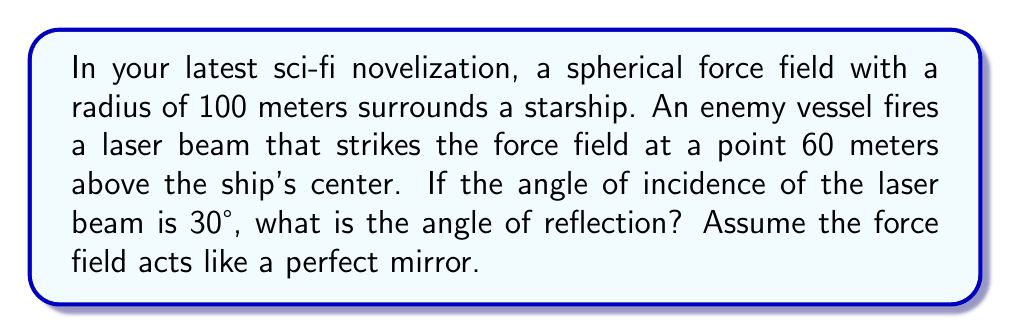Give your solution to this math problem. Let's approach this step-by-step:

1) In a curved surface, the angle of reflection is equal to the angle of incidence, but these angles are measured relative to the normal line at the point of incidence.

2) We need to find the normal line to the spherical force field at the point of incidence. This normal line will be a radius of the sphere.

3) Let's draw a diagram:

[asy]
import geometry;

size(200);

pair O = (0,0);
pair A = (0,60);
pair B = (86.6, 60);

draw(circle(O, 100), blue);
draw(O--A, dashed);
draw(A--B);
draw(A--(A.x-50,A.y), dashed);

label("O", O, SW);
label("A", A, E);
label("B", B, NE);
label("30°", (A.x-25,A.y), NW);
label("θ", (A.x+25,A.y), SE);
label("100m", (O.x+50,O.y+50), NE);
label("60m", (O.x-5,O.y+30), W);

draw(arc(A,20,270,300), Arrow);
draw(arc(A,20,240,270), Arrow);
[/asy]

4) In the diagram, O is the center of the sphere, A is the point of incidence, and B is a point on the incident ray.

5) We need to find the angle θ between OA and the vertical line.

6) In the right triangle OAX (where X is the point directly below A on the horizontal diameter):
   $$\cos θ = \frac{60}{100} = 0.6$$

7) Therefore:
   $$θ = \arccos(0.6) \approx 53.13°$$

8) The normal line at A is OA. The incident ray makes a 30° angle with this normal.

9) Since the angle of reflection equals the angle of incidence, the reflected ray will also make a 30° angle with the normal, but on the opposite side.

10) The angle of reflection relative to the vertical will be:
    $$53.13° + 30° = 83.13°$$
Answer: 83.13° 